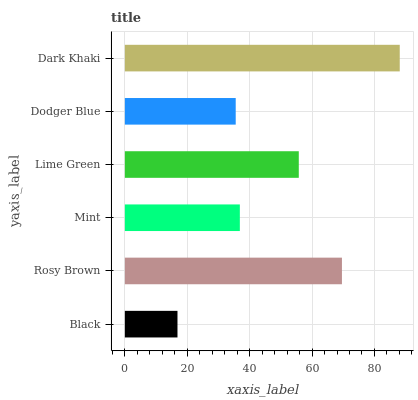Is Black the minimum?
Answer yes or no. Yes. Is Dark Khaki the maximum?
Answer yes or no. Yes. Is Rosy Brown the minimum?
Answer yes or no. No. Is Rosy Brown the maximum?
Answer yes or no. No. Is Rosy Brown greater than Black?
Answer yes or no. Yes. Is Black less than Rosy Brown?
Answer yes or no. Yes. Is Black greater than Rosy Brown?
Answer yes or no. No. Is Rosy Brown less than Black?
Answer yes or no. No. Is Lime Green the high median?
Answer yes or no. Yes. Is Mint the low median?
Answer yes or no. Yes. Is Black the high median?
Answer yes or no. No. Is Rosy Brown the low median?
Answer yes or no. No. 